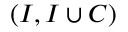Convert formula to latex. <formula><loc_0><loc_0><loc_500><loc_500>( I , I \cup C )</formula> 